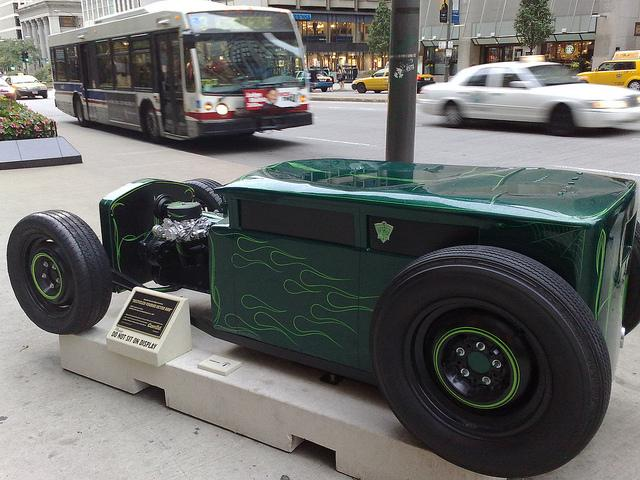Why is the car on the sidewalk? display 